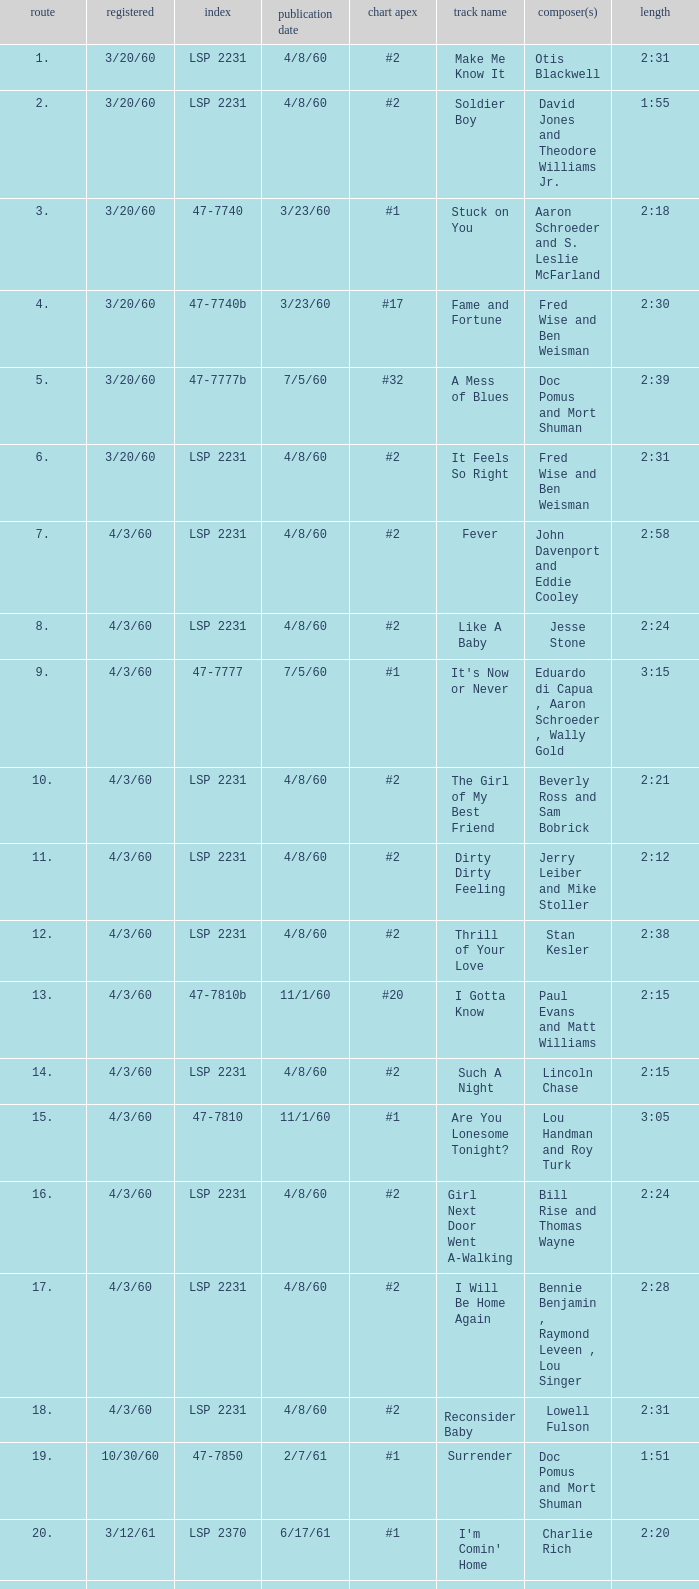Write the full table. {'header': ['route', 'registered', 'index', 'publication date', 'chart apex', 'track name', 'composer(s)', 'length'], 'rows': [['1.', '3/20/60', 'LSP 2231', '4/8/60', '#2', 'Make Me Know It', 'Otis Blackwell', '2:31'], ['2.', '3/20/60', 'LSP 2231', '4/8/60', '#2', 'Soldier Boy', 'David Jones and Theodore Williams Jr.', '1:55'], ['3.', '3/20/60', '47-7740', '3/23/60', '#1', 'Stuck on You', 'Aaron Schroeder and S. Leslie McFarland', '2:18'], ['4.', '3/20/60', '47-7740b', '3/23/60', '#17', 'Fame and Fortune', 'Fred Wise and Ben Weisman', '2:30'], ['5.', '3/20/60', '47-7777b', '7/5/60', '#32', 'A Mess of Blues', 'Doc Pomus and Mort Shuman', '2:39'], ['6.', '3/20/60', 'LSP 2231', '4/8/60', '#2', 'It Feels So Right', 'Fred Wise and Ben Weisman', '2:31'], ['7.', '4/3/60', 'LSP 2231', '4/8/60', '#2', 'Fever', 'John Davenport and Eddie Cooley', '2:58'], ['8.', '4/3/60', 'LSP 2231', '4/8/60', '#2', 'Like A Baby', 'Jesse Stone', '2:24'], ['9.', '4/3/60', '47-7777', '7/5/60', '#1', "It's Now or Never", 'Eduardo di Capua , Aaron Schroeder , Wally Gold', '3:15'], ['10.', '4/3/60', 'LSP 2231', '4/8/60', '#2', 'The Girl of My Best Friend', 'Beverly Ross and Sam Bobrick', '2:21'], ['11.', '4/3/60', 'LSP 2231', '4/8/60', '#2', 'Dirty Dirty Feeling', 'Jerry Leiber and Mike Stoller', '2:12'], ['12.', '4/3/60', 'LSP 2231', '4/8/60', '#2', 'Thrill of Your Love', 'Stan Kesler', '2:38'], ['13.', '4/3/60', '47-7810b', '11/1/60', '#20', 'I Gotta Know', 'Paul Evans and Matt Williams', '2:15'], ['14.', '4/3/60', 'LSP 2231', '4/8/60', '#2', 'Such A Night', 'Lincoln Chase', '2:15'], ['15.', '4/3/60', '47-7810', '11/1/60', '#1', 'Are You Lonesome Tonight?', 'Lou Handman and Roy Turk', '3:05'], ['16.', '4/3/60', 'LSP 2231', '4/8/60', '#2', 'Girl Next Door Went A-Walking', 'Bill Rise and Thomas Wayne', '2:24'], ['17.', '4/3/60', 'LSP 2231', '4/8/60', '#2', 'I Will Be Home Again', 'Bennie Benjamin , Raymond Leveen , Lou Singer', '2:28'], ['18.', '4/3/60', 'LSP 2231', '4/8/60', '#2', 'Reconsider Baby', 'Lowell Fulson', '2:31'], ['19.', '10/30/60', '47-7850', '2/7/61', '#1', 'Surrender', 'Doc Pomus and Mort Shuman', '1:51'], ['20.', '3/12/61', 'LSP 2370', '6/17/61', '#1', "I'm Comin' Home", 'Charlie Rich', '2:20'], ['21.', '3/12/61', 'LSP 2370', '6/17/61', '#1', 'Gently', 'Murray Wisell and Edward Lisbona', '2:15'], ['22.', '3/12/61', 'LSP 2370', '6/17/61', '#1', 'In Your Arms', 'Aaron Schroeder and Wally Gold', '1:50'], ['23.', '3/12/61', 'LSP 2370', '6/17/61', '#1', 'Give Me the Right', 'Fred Wise and Norman Blagman', '2:32'], ['24.', '3/12/61', '47-7880', '5/2/61', '#5', 'I Feel So Bad', 'Chuck Willis', '2:53'], ['25.', '3/12/61', 'LSP 2370', '6/17/61', '#1', "It's A Sin", 'Fred Rose and Zeb Turner', '2:39'], ['26.', '3/12/61', 'LSP 2370', '6/17/61', '#1', 'I Want You With Me', 'Woody Harris', '2:13'], ['27.', '3/12/61', 'LSP 2370', '6/17/61', '#1', "There's Always Me", 'Don Robertson', '2:16']]} What catalogue is the song It's Now or Never? 47-7777. 